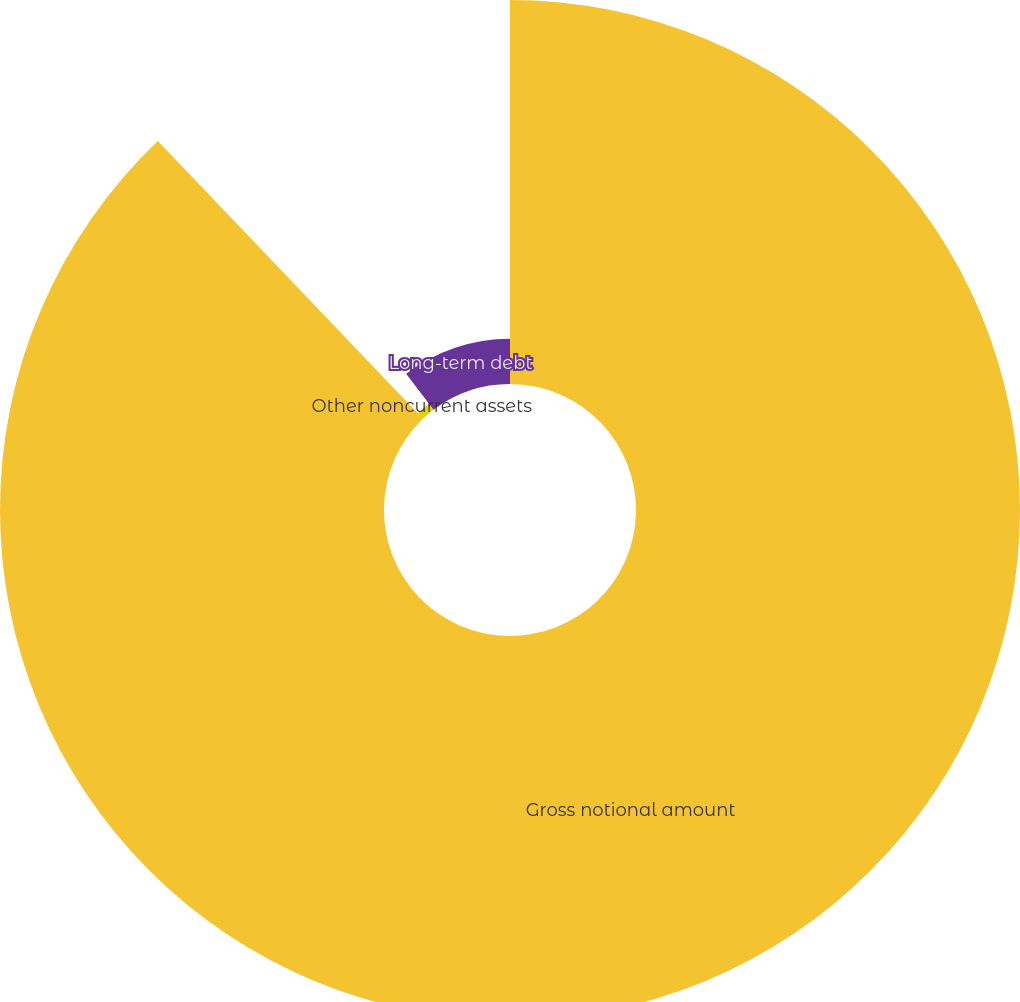Convert chart to OTSL. <chart><loc_0><loc_0><loc_500><loc_500><pie_chart><fcel>Gross notional amount<fcel>Other noncurrent assets<fcel>Long-term debt<nl><fcel>87.87%<fcel>1.76%<fcel>10.37%<nl></chart> 